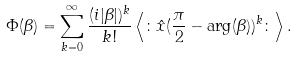Convert formula to latex. <formula><loc_0><loc_0><loc_500><loc_500>\Phi ( \beta ) = \sum _ { k = 0 } ^ { \infty } \frac { ( i | \beta | ) ^ { k } } { k ! } \left < \colon \hat { x } ( \frac { \pi } { 2 } - \arg ( \beta ) ) ^ { k } \colon \right > .</formula> 